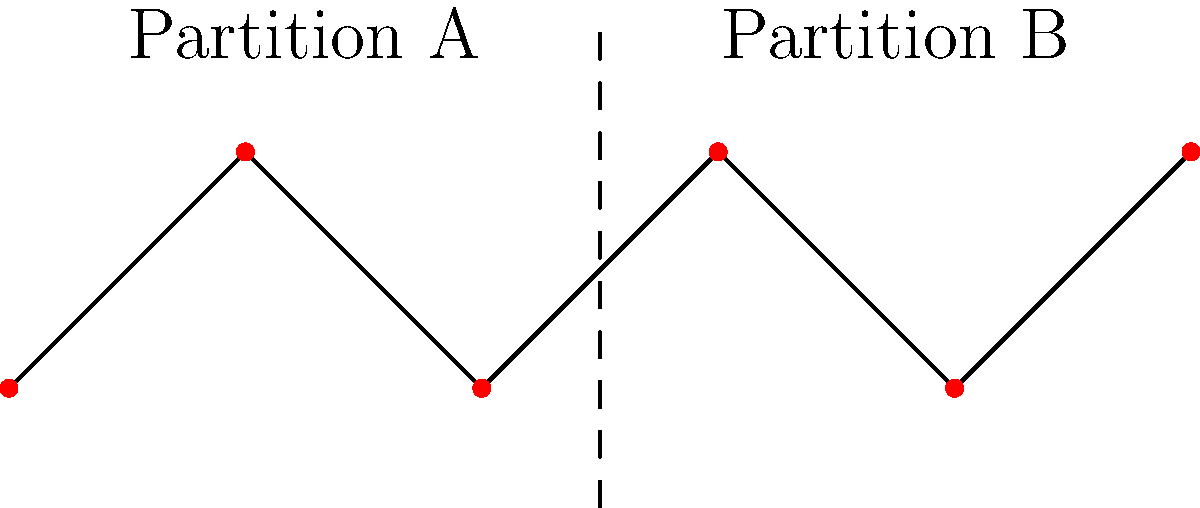In a blockchain network represented as a graph, how does applying a graph partitioning algorithm as shown in the diagram potentially improve scalability? What key metric should be minimized to ensure optimal partitioning for blockchain performance? To understand how graph partitioning improves blockchain scalability, let's follow these steps:

1. Graph representation: The blockchain network is represented as a graph, where nodes are participants and edges are connections.

2. Partitioning: The graph is divided into two or more partitions (A and B in the diagram).

3. Scalability improvement:
   a) Parallel processing: Each partition can process transactions independently.
   b) Reduced communication overhead: Nodes within a partition communicate more frequently than with nodes in other partitions.
   c) Load balancing: Workload is distributed across partitions.

4. Key metric to minimize: The number of edges cut by the partition (cross-partition edges).

5. Importance of minimizing cut edges:
   a) Reduces inter-partition communication.
   b) Decreases synchronization overhead.
   c) Improves overall system throughput.

6. Impact on blockchain:
   a) Faster transaction processing: Parallel execution in partitions.
   b) Improved consensus: Fewer nodes to coordinate within each partition.
   c) Enhanced network efficiency: Reduced global communication.

7. Challenges:
   a) Maintaining security and decentralization across partitions.
   b) Ensuring consistent state across the entire network.

The optimal partitioning minimizes cross-partition edges while balancing the load across partitions, leading to improved scalability in the blockchain system.
Answer: Minimize cross-partition edges 